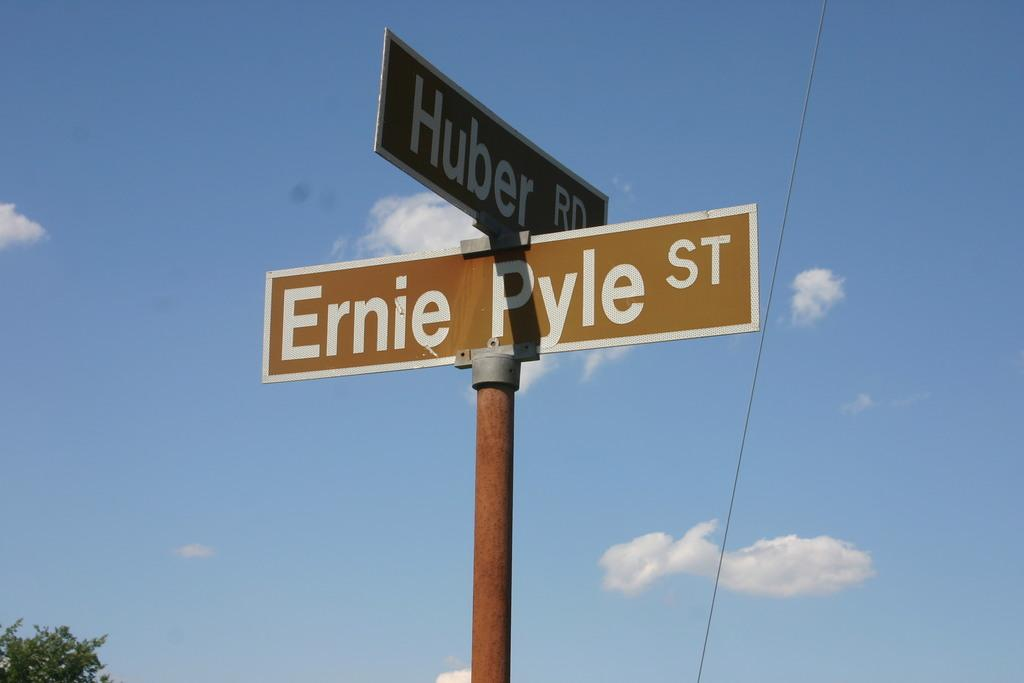<image>
Write a terse but informative summary of the picture. brown intersection street sign at Ernie Pyle St and Huber Rd 